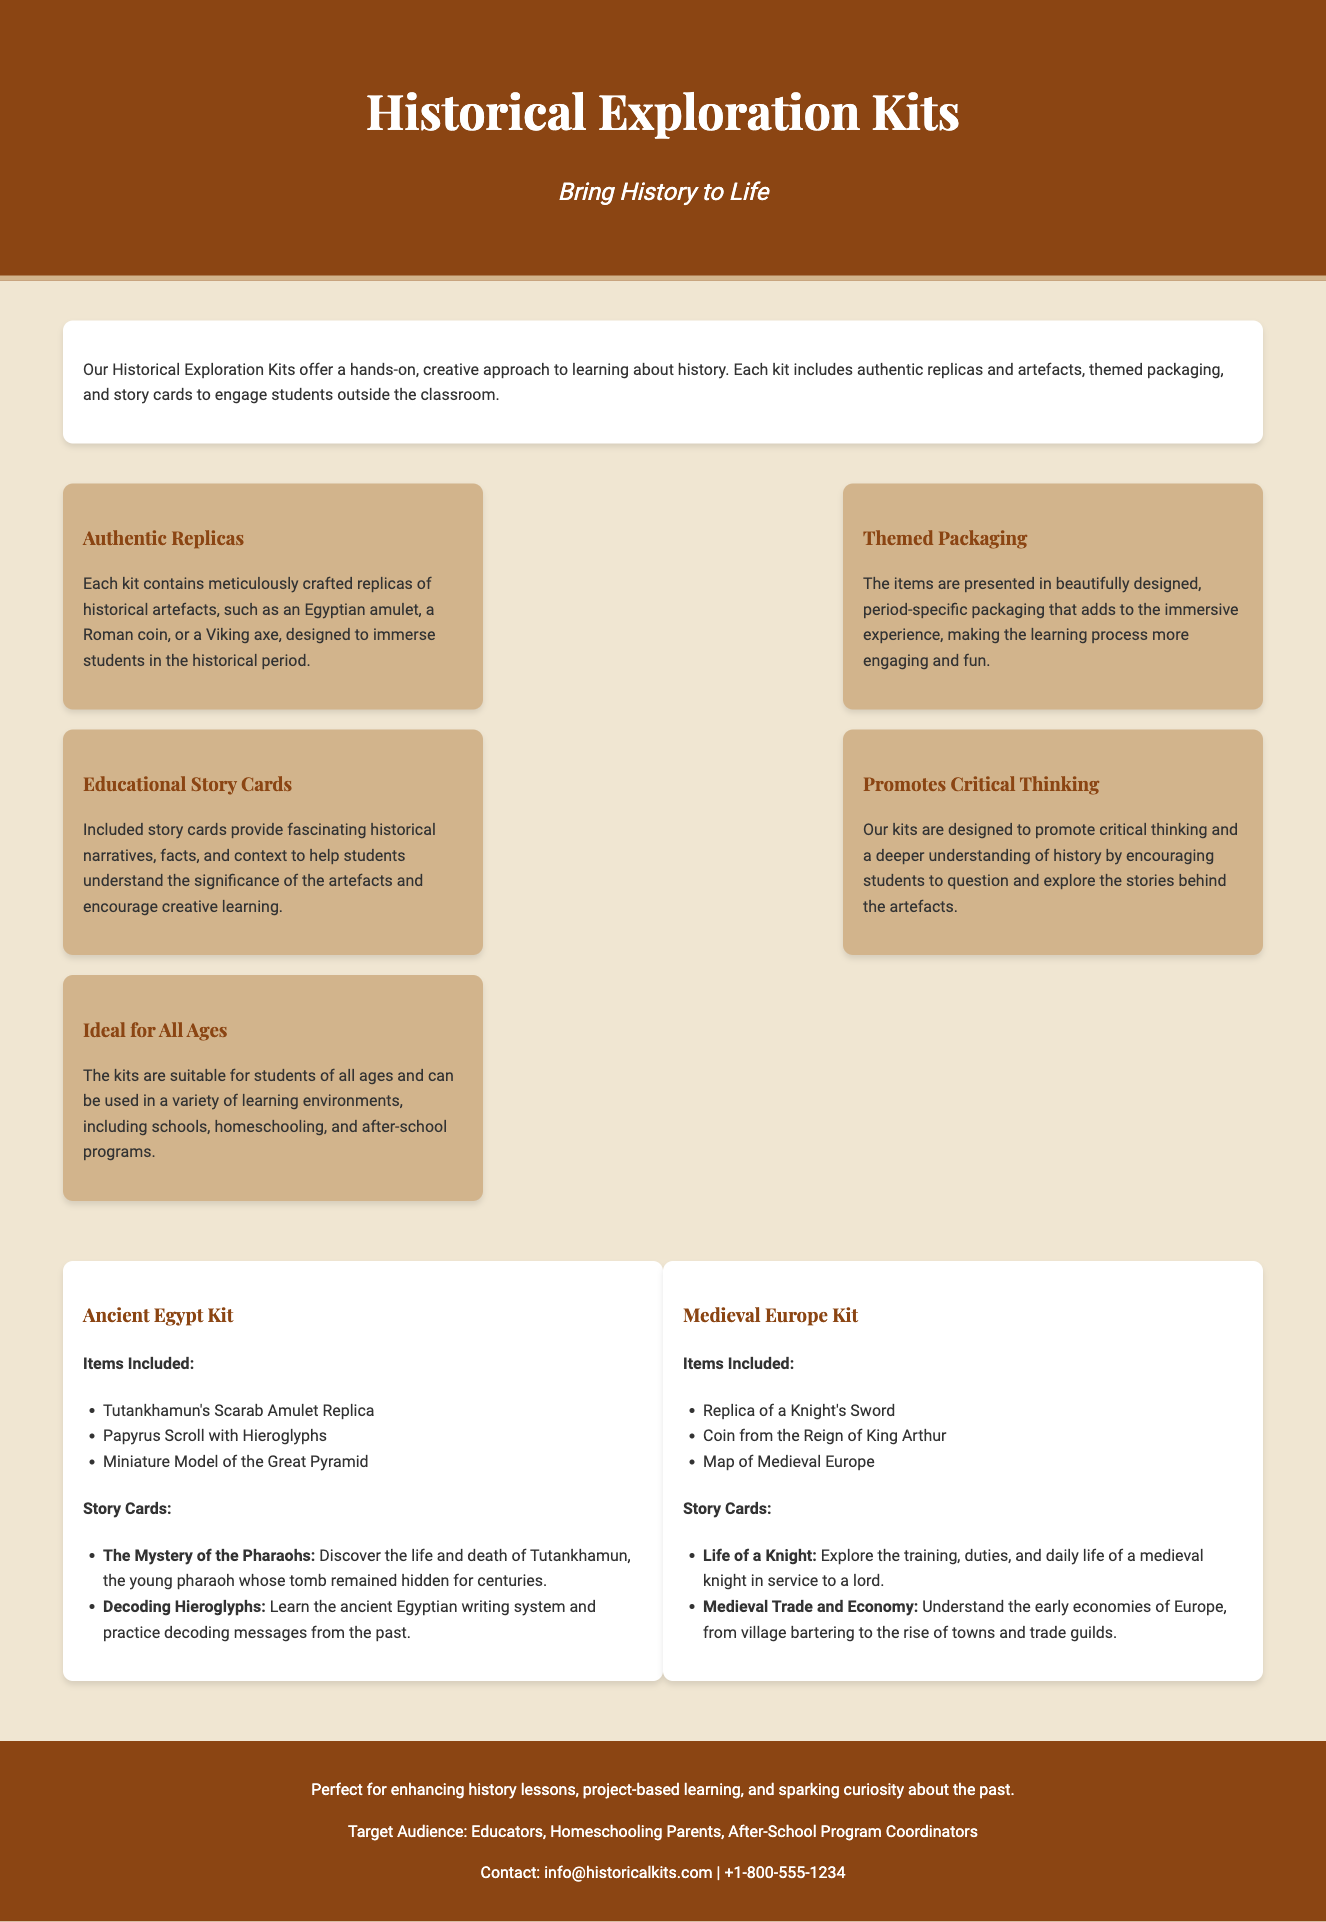What is the main theme of the Historical Exploration Kits? The description states that the kits offer a hands-on, creative approach to learning about history.
Answer: Creative approaches to learning about history How many examples of kits are provided in the document? There are two example kits mentioned under "example-kits."
Answer: Two Which historical period is represented in the Ancient Egypt Kit? The title of the kit indicates it is focused on Ancient Egypt.
Answer: Ancient Egypt What item is included in the Medieval Europe Kit? The section listing items clearly notes that a replica of a Knight's Sword is included.
Answer: Replica of a Knight's Sword What is provided alongside the artefacts in each kit? The description notes that "story cards" are included to engage students.
Answer: Story cards What is the benefit of the themed packaging? The document explains that themed packaging adds to the immersive experience.
Answer: Immersive experience Which skills do the kits promote? The document states that the kits are designed to promote critical thinking.
Answer: Critical thinking Who is the target audience for the Historical Exploration Kits? The footer mentions that the target audience includes educators, homeschooling parents, and after-school program coordinators.
Answer: Educators, Homeschooling Parents, After-School Program Coordinators 